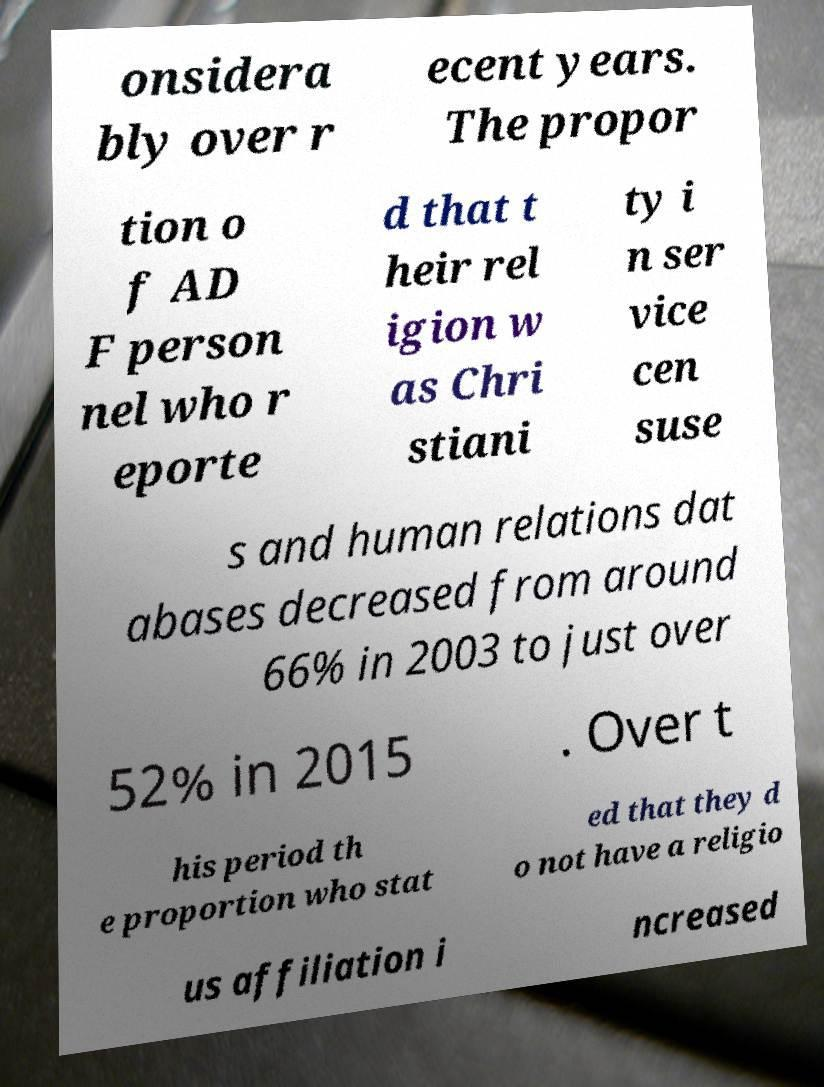Can you accurately transcribe the text from the provided image for me? onsidera bly over r ecent years. The propor tion o f AD F person nel who r eporte d that t heir rel igion w as Chri stiani ty i n ser vice cen suse s and human relations dat abases decreased from around 66% in 2003 to just over 52% in 2015 . Over t his period th e proportion who stat ed that they d o not have a religio us affiliation i ncreased 